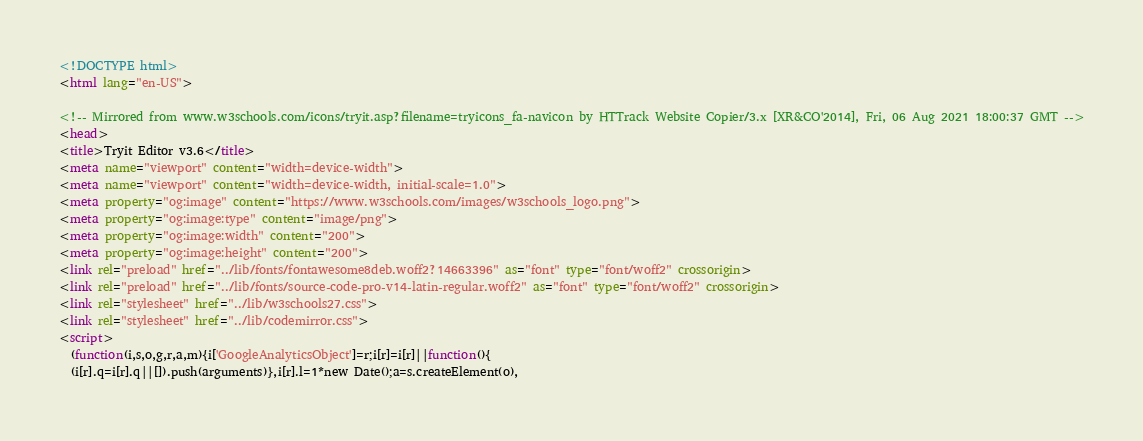Convert code to text. <code><loc_0><loc_0><loc_500><loc_500><_HTML_>
<!DOCTYPE html>
<html lang="en-US">

<!-- Mirrored from www.w3schools.com/icons/tryit.asp?filename=tryicons_fa-navicon by HTTrack Website Copier/3.x [XR&CO'2014], Fri, 06 Aug 2021 18:00:37 GMT -->
<head>
<title>Tryit Editor v3.6</title>
<meta name="viewport" content="width=device-width">
<meta name="viewport" content="width=device-width, initial-scale=1.0">
<meta property="og:image" content="https://www.w3schools.com/images/w3schools_logo.png">
<meta property="og:image:type" content="image/png">
<meta property="og:image:width" content="200">
<meta property="og:image:height" content="200">
<link rel="preload" href="../lib/fonts/fontawesome8deb.woff2?14663396" as="font" type="font/woff2" crossorigin> 
<link rel="preload" href="../lib/fonts/source-code-pro-v14-latin-regular.woff2" as="font" type="font/woff2" crossorigin> 
<link rel="stylesheet" href="../lib/w3schools27.css">
<link rel="stylesheet" href="../lib/codemirror.css">
<script>
  (function(i,s,o,g,r,a,m){i['GoogleAnalyticsObject']=r;i[r]=i[r]||function(){
  (i[r].q=i[r].q||[]).push(arguments)},i[r].l=1*new Date();a=s.createElement(o),</code> 